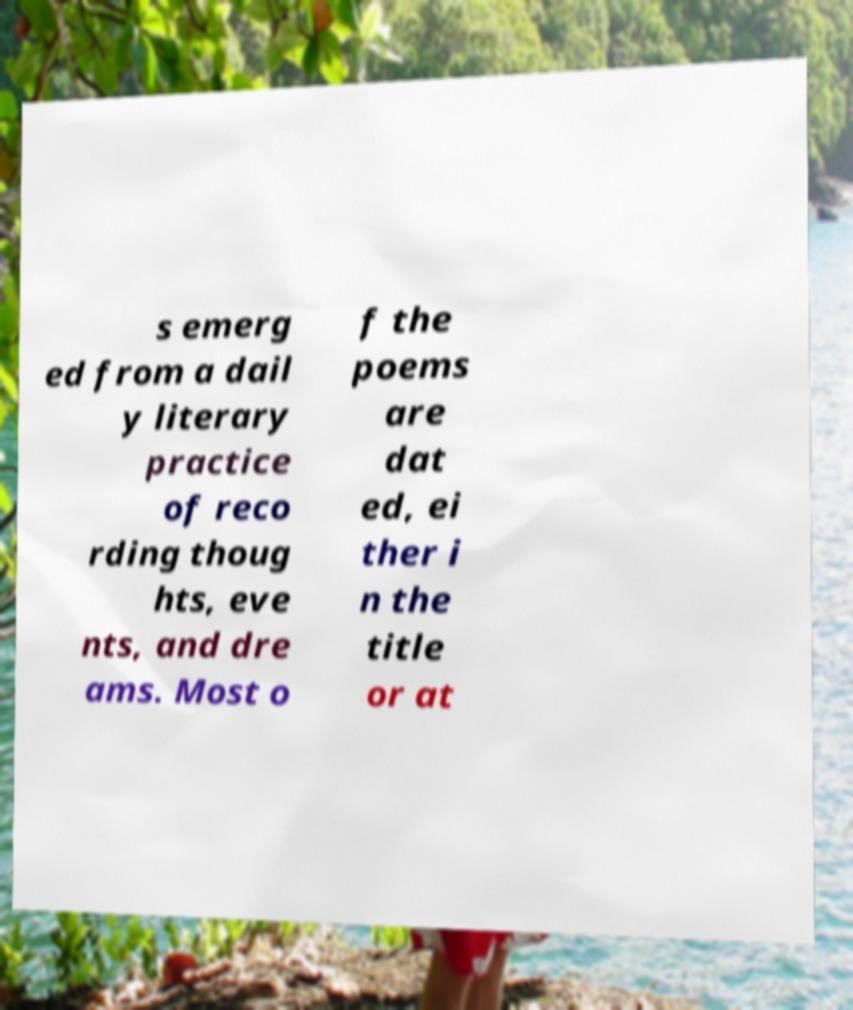Could you assist in decoding the text presented in this image and type it out clearly? s emerg ed from a dail y literary practice of reco rding thoug hts, eve nts, and dre ams. Most o f the poems are dat ed, ei ther i n the title or at 